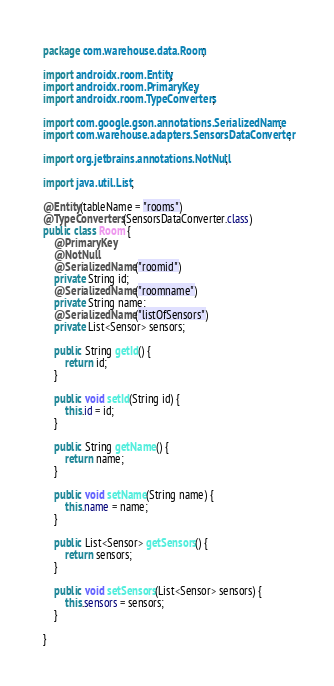<code> <loc_0><loc_0><loc_500><loc_500><_Java_>package com.warehouse.data.Room;

import androidx.room.Entity;
import androidx.room.PrimaryKey;
import androidx.room.TypeConverters;

import com.google.gson.annotations.SerializedName;
import com.warehouse.adapters.SensorsDataConverter;

import org.jetbrains.annotations.NotNull;

import java.util.List;

@Entity(tableName = "rooms")
@TypeConverters(SensorsDataConverter.class)
public class Room {
    @PrimaryKey
    @NotNull
    @SerializedName("roomid")
    private String id;
    @SerializedName("roomname")
    private String name;
    @SerializedName("listOfSensors")
    private List<Sensor> sensors;

    public String getId() {
        return id;
    }

    public void setId(String id) {
        this.id = id;
    }

    public String getName() {
        return name;
    }

    public void setName(String name) {
        this.name = name;
    }

    public List<Sensor> getSensors() {
        return sensors;
    }

    public void setSensors(List<Sensor> sensors) {
        this.sensors = sensors;
    }

}
</code> 